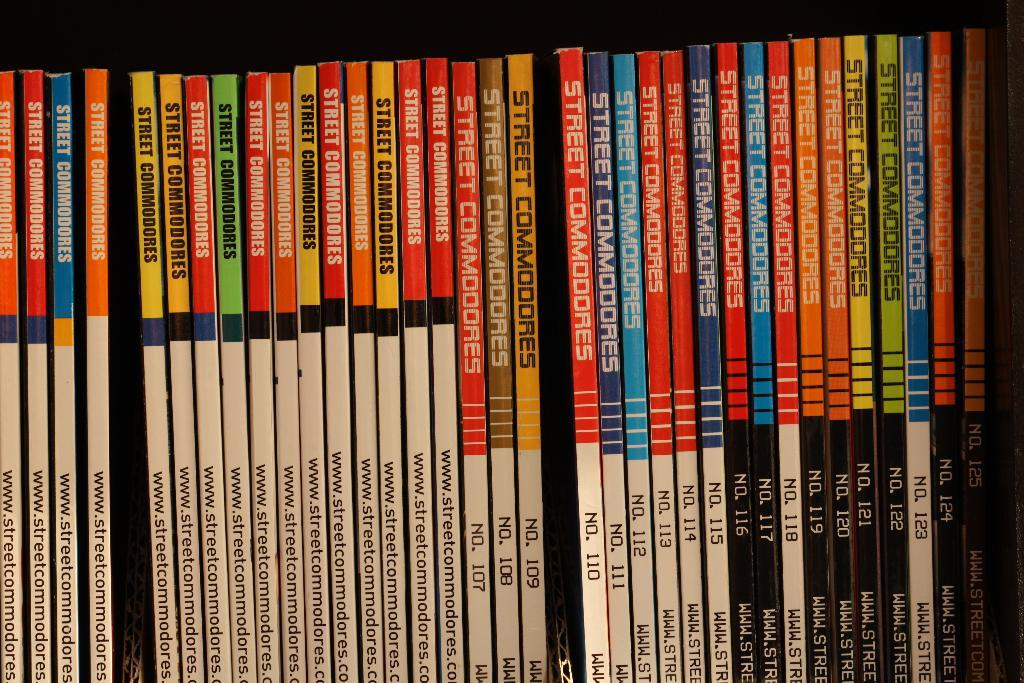<image>
Describe the image concisely. A collection of Street Commanders books sit on a shelf sorted by volumes 